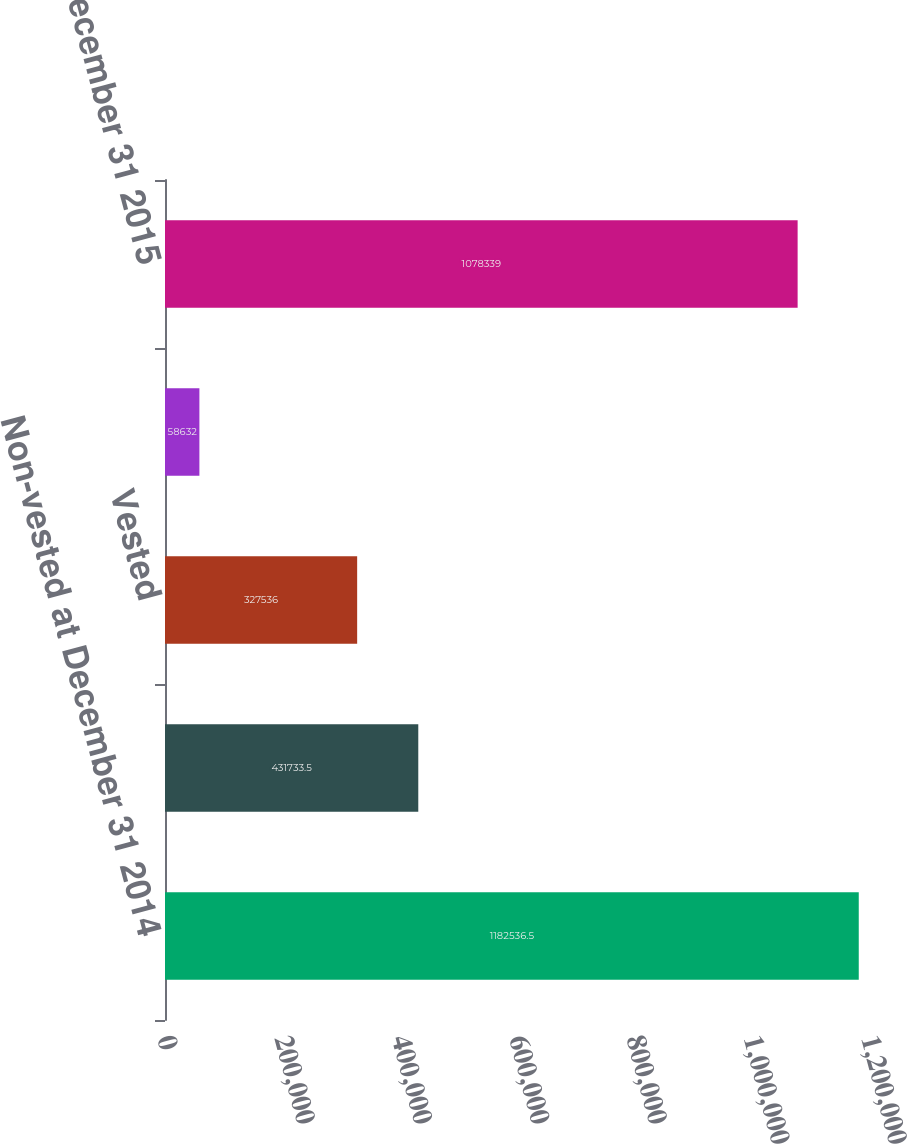Convert chart. <chart><loc_0><loc_0><loc_500><loc_500><bar_chart><fcel>Non-vested at December 31 2014<fcel>Granted<fcel>Vested<fcel>Forfeited<fcel>Non-vested at December 31 2015<nl><fcel>1.18254e+06<fcel>431734<fcel>327536<fcel>58632<fcel>1.07834e+06<nl></chart> 